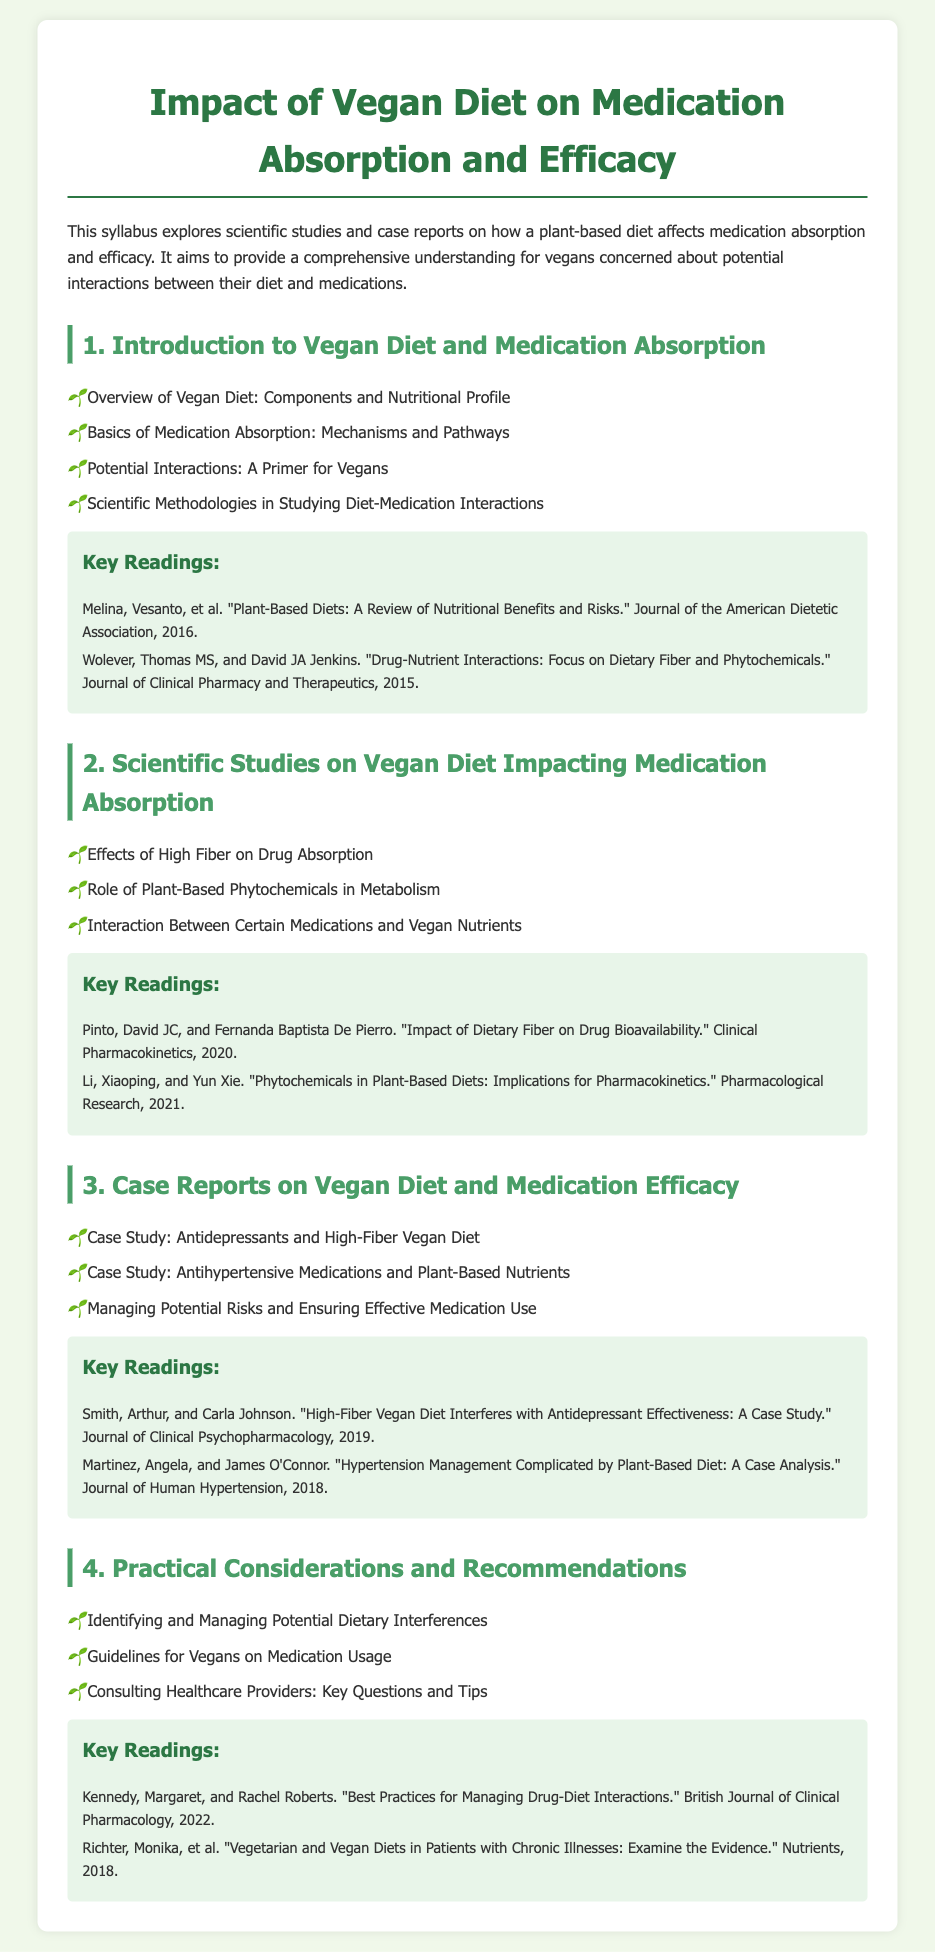what is the title of the syllabus? The title of the syllabus is prominently displayed at the top of the document.
Answer: Impact of Vegan Diet on Medication Absorption and Efficacy what is the first topic discussed in the syllabus? The first topic is listed under the numbered sections.
Answer: Introduction to Vegan Diet and Medication Absorption who is the author of the key reading about dietary fiber and drug interactions? The author is mentioned in the key readings section under the respective topics.
Answer: Thomas MS Wolever how many case studies are mentioned in the third section? The number of case studies is indicated by the list items in the section.
Answer: Three what is one of the key recommendations for vegans on medication usage? The recommendations are highlighted in the last section of the syllabus.
Answer: Guidelines for Vegans on Medication Usage what year was the review on plant-based diets published? The publication year is noted in the citations of the key readings.
Answer: 2016 what type of diet is specifically mentioned to potentially interfere with antidepressants? This information is found in the case study titles under the third section.
Answer: High-Fiber Vegan Diet who are the authors of the case analysis on hypertension management? The authors are listed in the key readings section under the third topic.
Answer: Angela Martinez and James O'Connor what is emphasized as important when managing drug-diet interactions? The emphasis is stated in the last section of the syllabus.
Answer: Consulting Healthcare Providers 